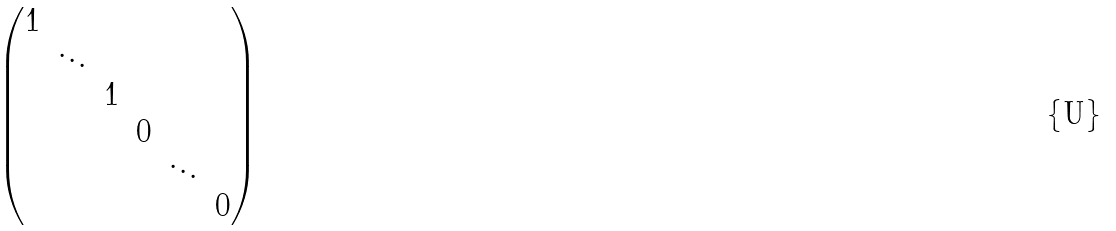Convert formula to latex. <formula><loc_0><loc_0><loc_500><loc_500>\begin{pmatrix} 1 & & & & & \\ & \ddots & & & & \\ & & 1 & & & \\ & & & 0 & & \\ & & & & \ddots & \\ & & & & & 0 \\ \end{pmatrix}</formula> 